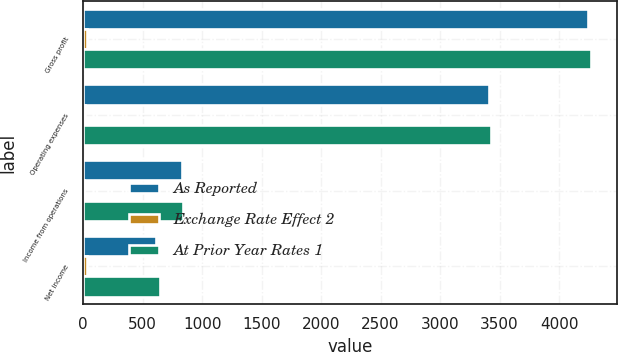Convert chart. <chart><loc_0><loc_0><loc_500><loc_500><stacked_bar_chart><ecel><fcel>Gross profit<fcel>Operating expenses<fcel>Income from operations<fcel>Net income<nl><fcel>As Reported<fcel>4240<fcel>3408<fcel>832<fcel>609<nl><fcel>Exchange Rate Effect 2<fcel>30<fcel>20<fcel>10<fcel>36<nl><fcel>At Prior Year Rates 1<fcel>4270<fcel>3428<fcel>842<fcel>645<nl></chart> 